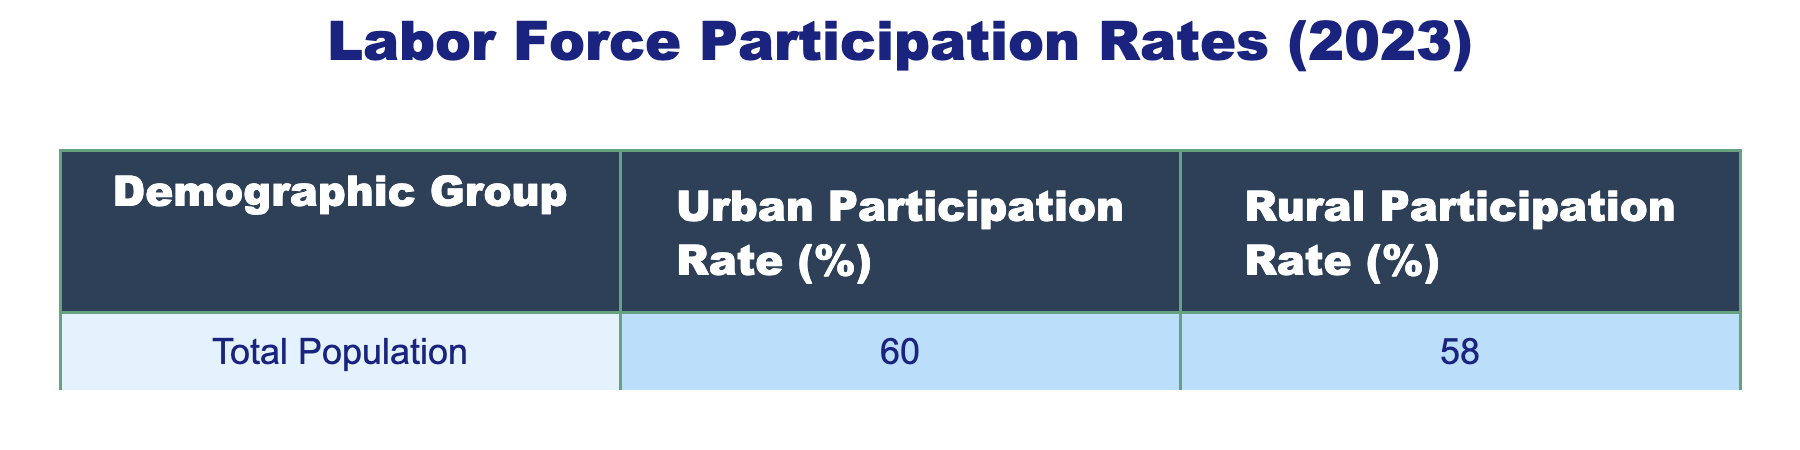What is the urban labor force participation rate for the total population? The table shows that the urban participation rate for the total population is 60 percent.
Answer: 60% What is the rural labor force participation rate for the total population? According to the table, the rural participation rate for the total population is 58 percent.
Answer: 58% Is the urban participation rate greater than the rural participation rate for the total population? Yes, the urban participation rate of 60 percent is greater than the rural participation rate of 58 percent.
Answer: Yes What is the difference between urban and rural participation rates for the total population? The difference can be calculated by subtracting the rural participation rate (58) from the urban participation rate (60). Therefore, the difference is 60 - 58 = 2.
Answer: 2 If a demographic group had a rural participation rate of 62 percent, would it have a higher rural participation rate than the total population? Yes, 62 percent is higher than the total population's rural participation rate of 58 percent.
Answer: Yes What is the average of urban and rural participation rates for the total population? The average can be calculated by adding the urban and rural rates (60 + 58) and dividing by 2. So, the average is (60 + 58) / 2 = 59 percent.
Answer: 59% Are both urban and rural participation rates for the total population above 50 percent? Yes, both rates (60 percent for urban and 58 percent for rural) are above 50 percent.
Answer: Yes Which participation rate is closer to 60 percent for the total population: urban or rural? Since the urban participation rate is 60 percent and the rural participation rate is 58 percent, the rural rate is closer to 60 percent, as it is only 2 percent less.
Answer: Rural If the urban participation rate increased by 5 percent, what would it be? To find the new urban participation rate, add 5 percent to the current urban rate (60 + 5 = 65). Therefore, the new urban participation rate would be 65 percent.
Answer: 65% 